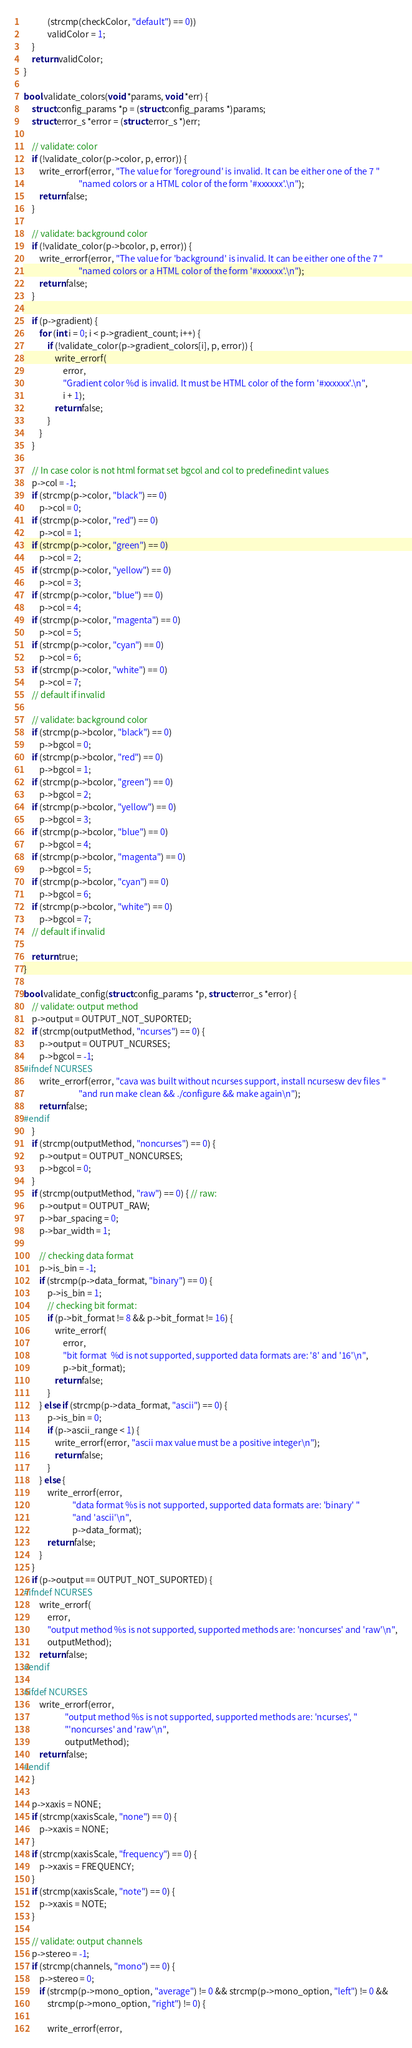<code> <loc_0><loc_0><loc_500><loc_500><_C_>            (strcmp(checkColor, "default") == 0))
            validColor = 1;
    }
    return validColor;
}

bool validate_colors(void *params, void *err) {
    struct config_params *p = (struct config_params *)params;
    struct error_s *error = (struct error_s *)err;

    // validate: color
    if (!validate_color(p->color, p, error)) {
        write_errorf(error, "The value for 'foreground' is invalid. It can be either one of the 7 "
                            "named colors or a HTML color of the form '#xxxxxx'.\n");
        return false;
    }

    // validate: background color
    if (!validate_color(p->bcolor, p, error)) {
        write_errorf(error, "The value for 'background' is invalid. It can be either one of the 7 "
                            "named colors or a HTML color of the form '#xxxxxx'.\n");
        return false;
    }

    if (p->gradient) {
        for (int i = 0; i < p->gradient_count; i++) {
            if (!validate_color(p->gradient_colors[i], p, error)) {
                write_errorf(
                    error,
                    "Gradient color %d is invalid. It must be HTML color of the form '#xxxxxx'.\n",
                    i + 1);
                return false;
            }
        }
    }

    // In case color is not html format set bgcol and col to predefinedint values
    p->col = -1;
    if (strcmp(p->color, "black") == 0)
        p->col = 0;
    if (strcmp(p->color, "red") == 0)
        p->col = 1;
    if (strcmp(p->color, "green") == 0)
        p->col = 2;
    if (strcmp(p->color, "yellow") == 0)
        p->col = 3;
    if (strcmp(p->color, "blue") == 0)
        p->col = 4;
    if (strcmp(p->color, "magenta") == 0)
        p->col = 5;
    if (strcmp(p->color, "cyan") == 0)
        p->col = 6;
    if (strcmp(p->color, "white") == 0)
        p->col = 7;
    // default if invalid

    // validate: background color
    if (strcmp(p->bcolor, "black") == 0)
        p->bgcol = 0;
    if (strcmp(p->bcolor, "red") == 0)
        p->bgcol = 1;
    if (strcmp(p->bcolor, "green") == 0)
        p->bgcol = 2;
    if (strcmp(p->bcolor, "yellow") == 0)
        p->bgcol = 3;
    if (strcmp(p->bcolor, "blue") == 0)
        p->bgcol = 4;
    if (strcmp(p->bcolor, "magenta") == 0)
        p->bgcol = 5;
    if (strcmp(p->bcolor, "cyan") == 0)
        p->bgcol = 6;
    if (strcmp(p->bcolor, "white") == 0)
        p->bgcol = 7;
    // default if invalid

    return true;
}

bool validate_config(struct config_params *p, struct error_s *error) {
    // validate: output method
    p->output = OUTPUT_NOT_SUPORTED;
    if (strcmp(outputMethod, "ncurses") == 0) {
        p->output = OUTPUT_NCURSES;
        p->bgcol = -1;
#ifndef NCURSES
        write_errorf(error, "cava was built without ncurses support, install ncursesw dev files "
                            "and run make clean && ./configure && make again\n");
        return false;
#endif
    }
    if (strcmp(outputMethod, "noncurses") == 0) {
        p->output = OUTPUT_NONCURSES;
        p->bgcol = 0;
    }
    if (strcmp(outputMethod, "raw") == 0) { // raw:
        p->output = OUTPUT_RAW;
        p->bar_spacing = 0;
        p->bar_width = 1;

        // checking data format
        p->is_bin = -1;
        if (strcmp(p->data_format, "binary") == 0) {
            p->is_bin = 1;
            // checking bit format:
            if (p->bit_format != 8 && p->bit_format != 16) {
                write_errorf(
                    error,
                    "bit format  %d is not supported, supported data formats are: '8' and '16'\n",
                    p->bit_format);
                return false;
            }
        } else if (strcmp(p->data_format, "ascii") == 0) {
            p->is_bin = 0;
            if (p->ascii_range < 1) {
                write_errorf(error, "ascii max value must be a positive integer\n");
                return false;
            }
        } else {
            write_errorf(error,
                         "data format %s is not supported, supported data formats are: 'binary' "
                         "and 'ascii'\n",
                         p->data_format);
            return false;
        }
    }
    if (p->output == OUTPUT_NOT_SUPORTED) {
#ifndef NCURSES
        write_errorf(
            error,
            "output method %s is not supported, supported methods are: 'noncurses' and 'raw'\n",
            outputMethod);
        return false;
#endif

#ifdef NCURSES
        write_errorf(error,
                     "output method %s is not supported, supported methods are: 'ncurses', "
                     "'noncurses' and 'raw'\n",
                     outputMethod);
        return false;
#endif
    }

    p->xaxis = NONE;
    if (strcmp(xaxisScale, "none") == 0) {
        p->xaxis = NONE;
    }
    if (strcmp(xaxisScale, "frequency") == 0) {
        p->xaxis = FREQUENCY;
    }
    if (strcmp(xaxisScale, "note") == 0) {
        p->xaxis = NOTE;
    }

    // validate: output channels
    p->stereo = -1;
    if (strcmp(channels, "mono") == 0) {
        p->stereo = 0;
        if (strcmp(p->mono_option, "average") != 0 && strcmp(p->mono_option, "left") != 0 &&
            strcmp(p->mono_option, "right") != 0) {

            write_errorf(error,</code> 